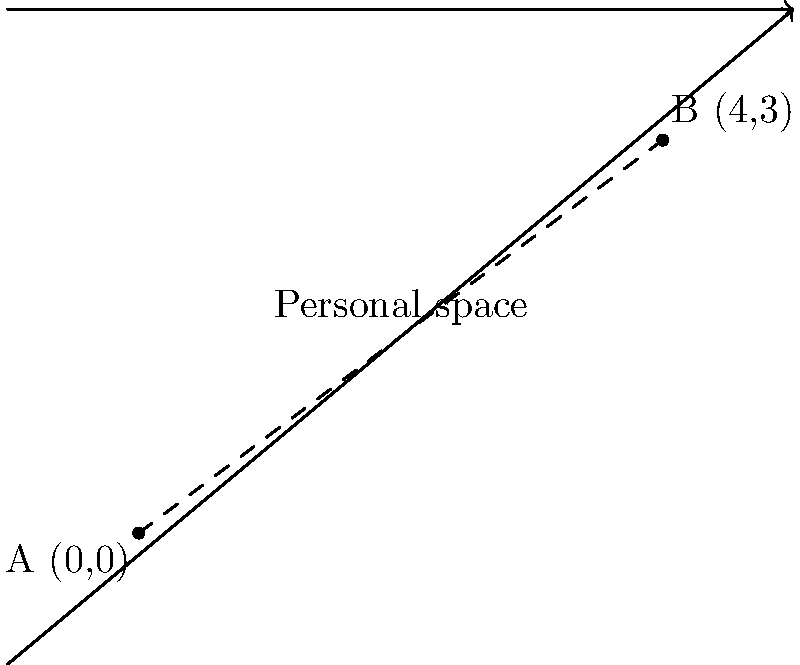In a classroom setting, two students are represented by points A(0,0) and B(4,3) on a coordinate plane. To teach the concept of personal space, you need to calculate the distance between these two points. Using the distance formula, determine how far apart the students are standing. How might this distance relate to personal space concepts in child development? To solve this problem, we'll use the distance formula derived from the Pythagorean theorem:

1) The distance formula is: 
   $$d = \sqrt{(x_2-x_1)^2 + (y_2-y_1)^2}$$

2) We have two points:
   A(0,0) and B(4,3)
   So, $(x_1,y_1) = (0,0)$ and $(x_2,y_2) = (4,3)$

3) Let's plug these into the formula:
   $$d = \sqrt{(4-0)^2 + (3-0)^2}$$

4) Simplify:
   $$d = \sqrt{4^2 + 3^2} = \sqrt{16 + 9} = \sqrt{25} = 5$$

5) Therefore, the distance between the two students is 5 units.

In terms of personal space concepts:
- This distance can be used to illustrate appropriate personal space in various social situations.
- It can demonstrate how personal space needs may vary in different contexts (e.g., classroom vs. playground).
- The concept can be extended to discuss cultural differences in personal space preferences.
- It can be used to teach respect for others' boundaries and spatial awareness.
Answer: 5 units 